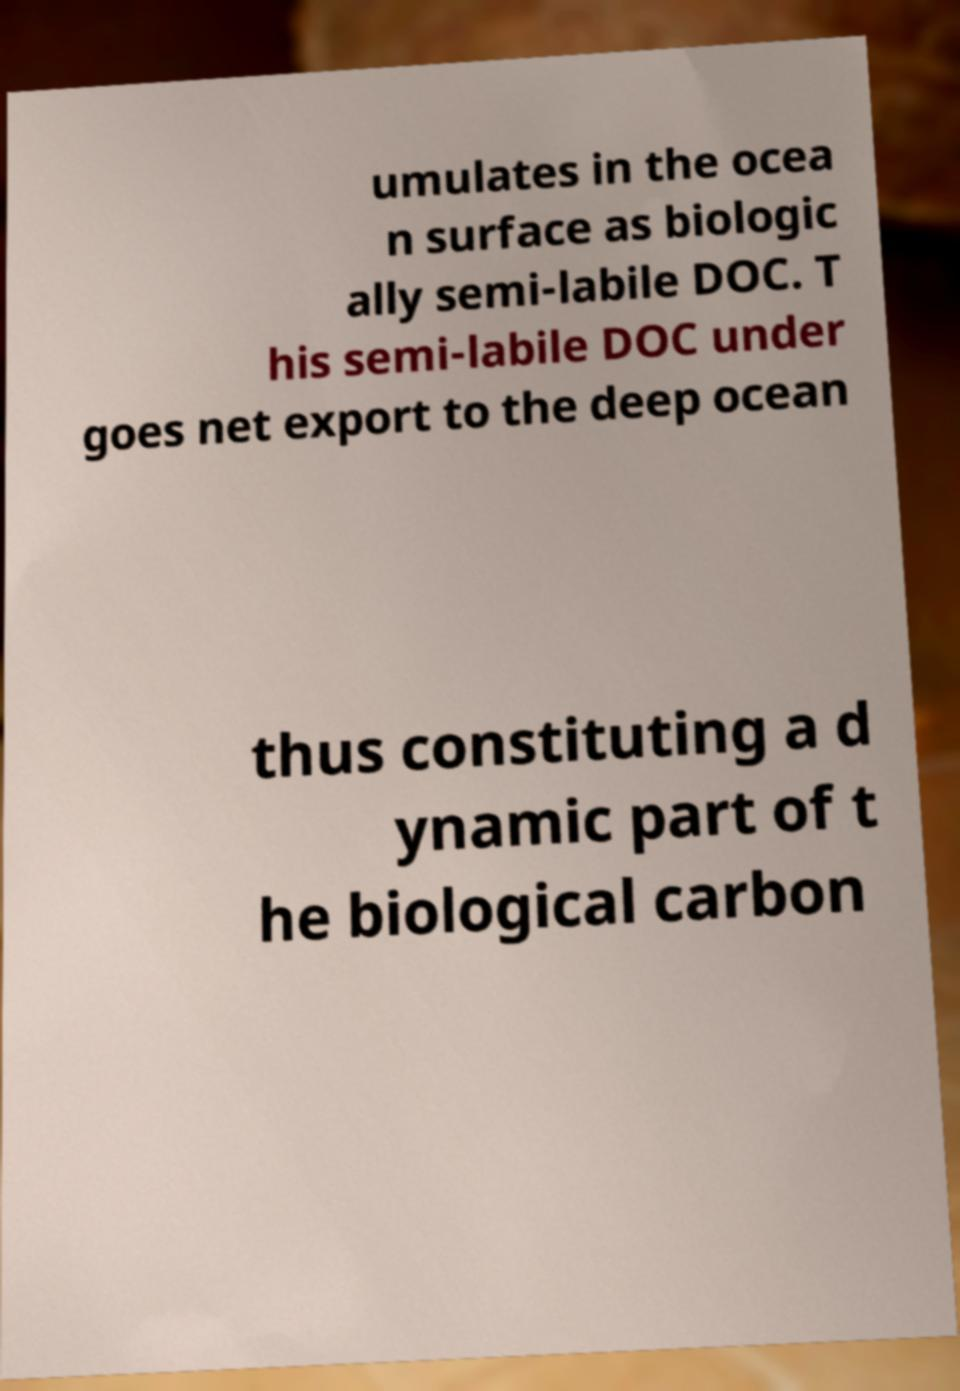Could you extract and type out the text from this image? umulates in the ocea n surface as biologic ally semi-labile DOC. T his semi-labile DOC under goes net export to the deep ocean thus constituting a d ynamic part of t he biological carbon 